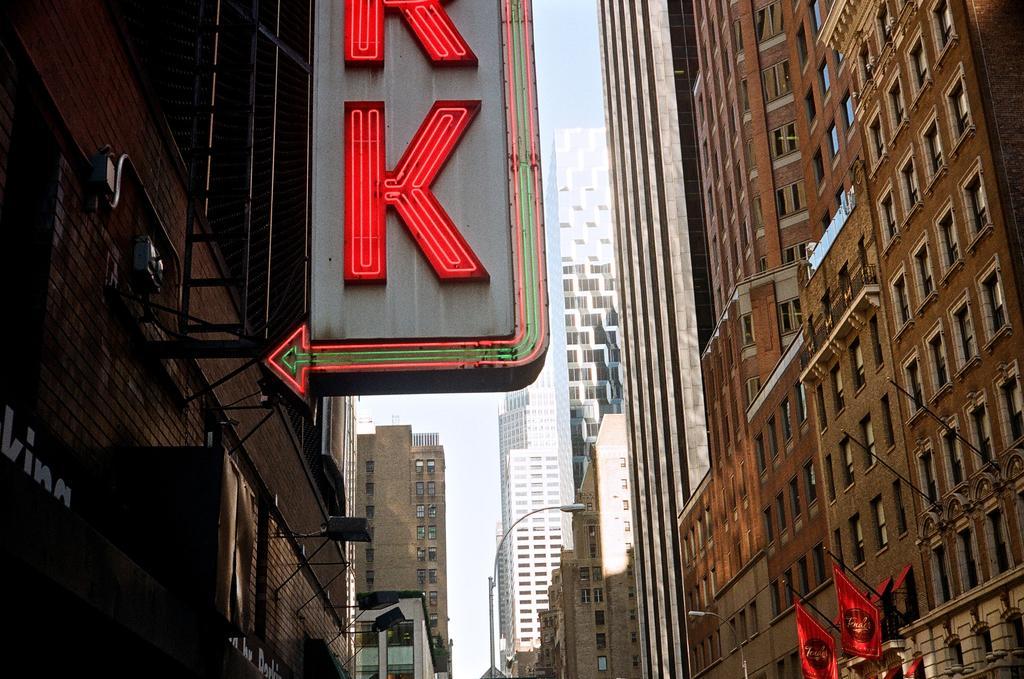Describe this image in one or two sentences. In this image there is a hoarding in the middle. On the hoarding there are letters with the led lights. There are buildings on either side of the image. At the top there is the sky. On the right side bottom there are two flags to the building. 